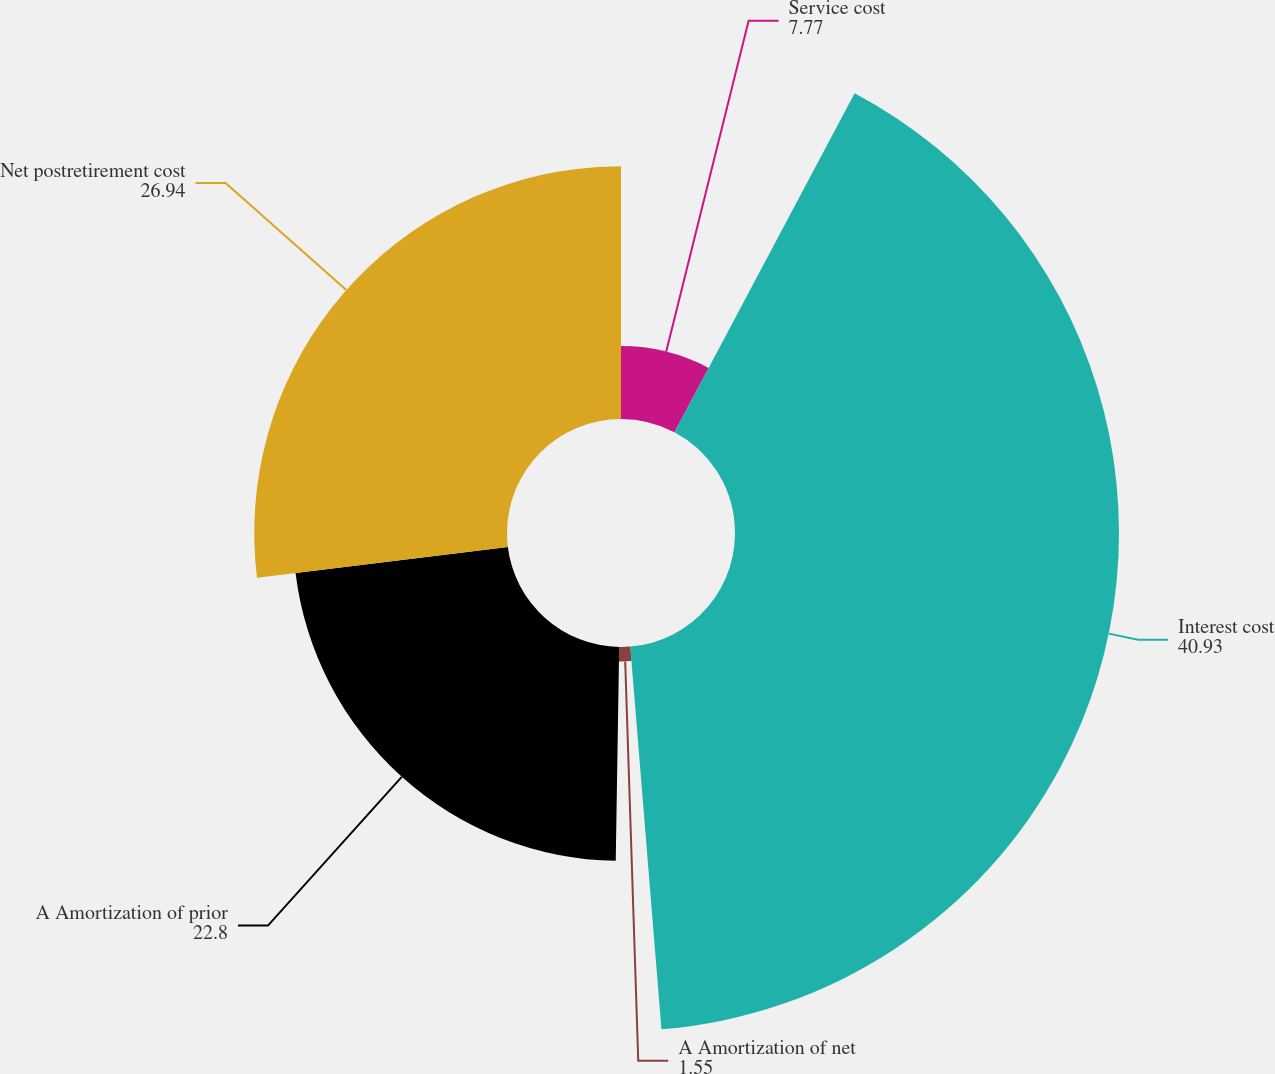Convert chart. <chart><loc_0><loc_0><loc_500><loc_500><pie_chart><fcel>Service cost<fcel>Interest cost<fcel>A Amortization of net<fcel>A Amortization of prior<fcel>Net postretirement cost<nl><fcel>7.77%<fcel>40.93%<fcel>1.55%<fcel>22.8%<fcel>26.94%<nl></chart> 